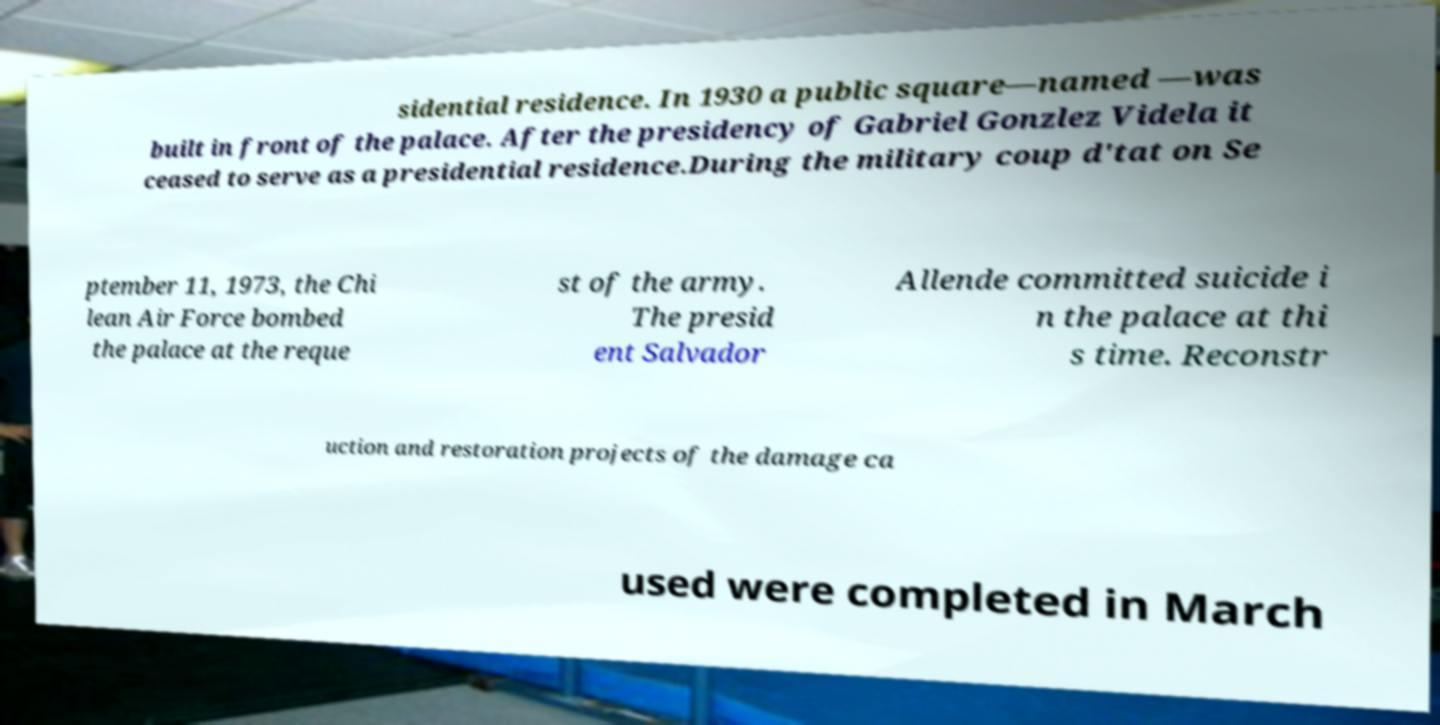I need the written content from this picture converted into text. Can you do that? sidential residence. In 1930 a public square—named —was built in front of the palace. After the presidency of Gabriel Gonzlez Videla it ceased to serve as a presidential residence.During the military coup d'tat on Se ptember 11, 1973, the Chi lean Air Force bombed the palace at the reque st of the army. The presid ent Salvador Allende committed suicide i n the palace at thi s time. Reconstr uction and restoration projects of the damage ca used were completed in March 